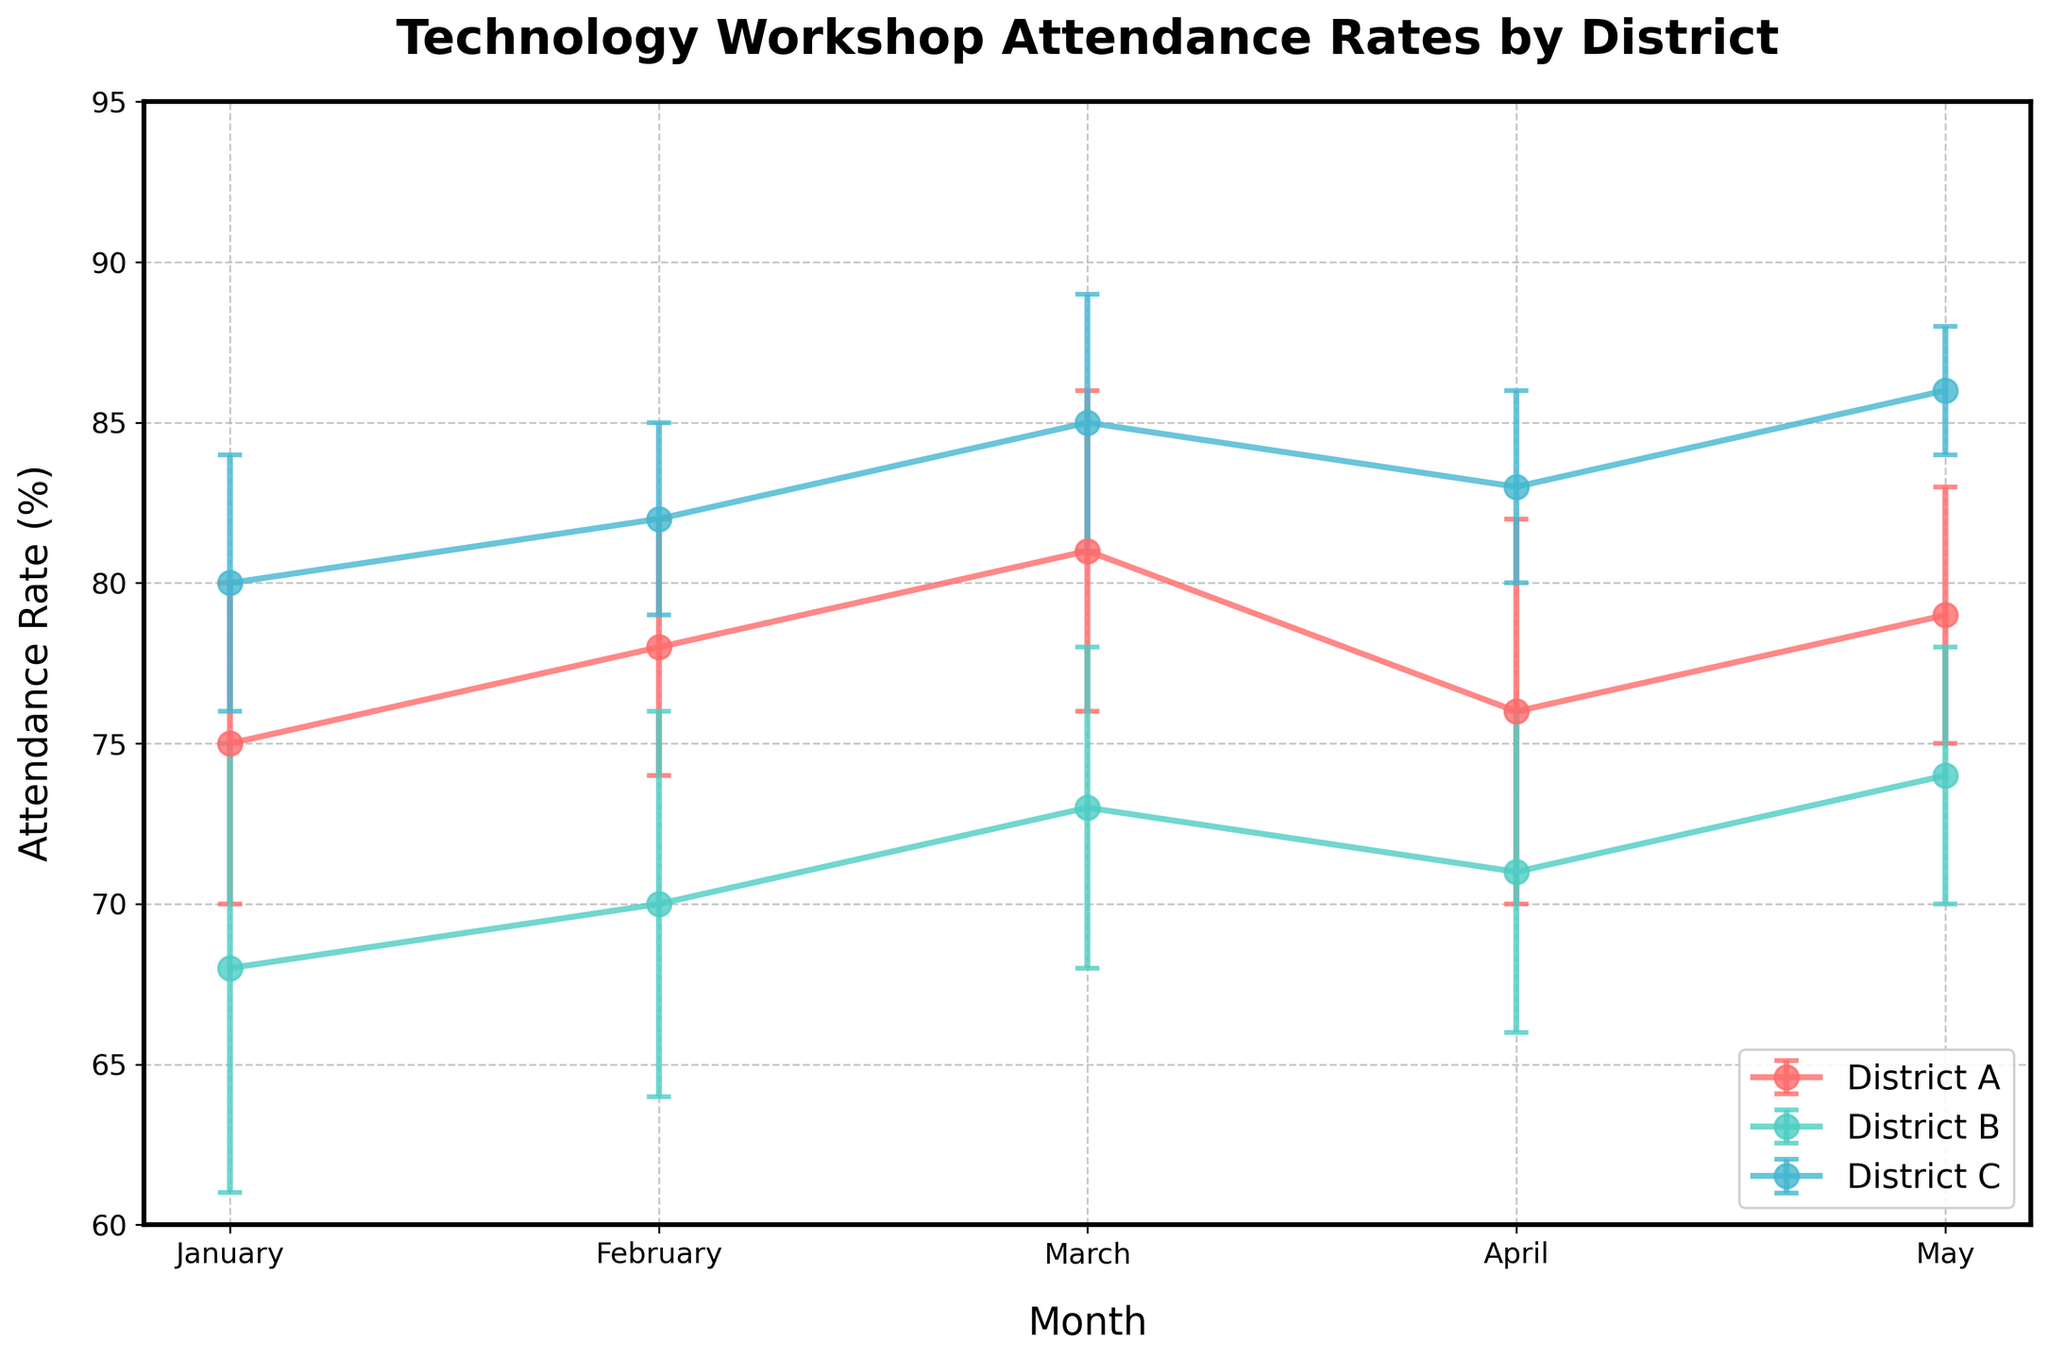what is the title of the plot? The title of the plot is displayed at the top center and usually summarizes the content or theme of the plot. In this case, it summarizes the subject of the data shown in the plot.
Answer: Technology Workshop Attendance Rates by District Which months have data points plotted in the figure? The x-axis represents the months. Each month is explicitly labeled with data points indicated for those months. In this plot, the specific months are January, February, March, April, and May.
Answer: January, February, March, April, May What is the attendance rate for District C in April? To determine this, locate the data point for District C (which has a specific line color) on the April section of the x-axis. The y-coordinate of this point indicates the attendance rate.
Answer: 83% Which district has the highest average attendance rate across the entire period? To find this out, average the attendance rates for each district over the five months and compare the results. Calculating District A's average rate: (75+78+81+76+79)/5 = 77.8, District B: (68+70+73+71+74)/5 = 71.2, District C: (80+82+85+83+86)/5 = 83.2, the highest value belongs to District C.
Answer: District C Do any months show overlapping attendance rates between the districts? Look at each month's data points. Districts with the same or very close attendance rates will have their points plotted very close to each other or overlapping. This requires closely inspecting the plot for such overlaps.
Answer: No Which district shows the most fluctuation in attendance rates month-over-month? The fluctuations can be visualized by the error bars and the ups and downs of each line plot. Calculate the range (minimum attendance to maximum attendance) for each district. For District A: 81-75 = 6, District B: 74-68 = 6, District C: 86-80 = 6. All have the same fluctuation range.
Answer: All districts have the same range of fluctuation What is the error margin for District B in February? Refer to the error bar associated with the February data point for District B by matching the color and line style for District B. The error margin is visually indicated and typically listed in a ± format.
Answer: ±6 By looking at District C's trend, does the attendance rate increase, decrease, or remain stable over time? Observing District C's line from January to May, note the trend direction. The data points show a generally upward trend, indicating an increase in the attendance rate over time.
Answer: Increase Compare the attendance rates of District A and District B in March. Which district had higher attendance? Look at the data points for both District A and District B for March. District A's attendance is 81%, while District B's is 73%, so District A has the higher attendance.
Answer: District A 